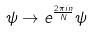<formula> <loc_0><loc_0><loc_500><loc_500>\psi \rightarrow e ^ { \frac { 2 \pi i n } { N } } \psi</formula> 